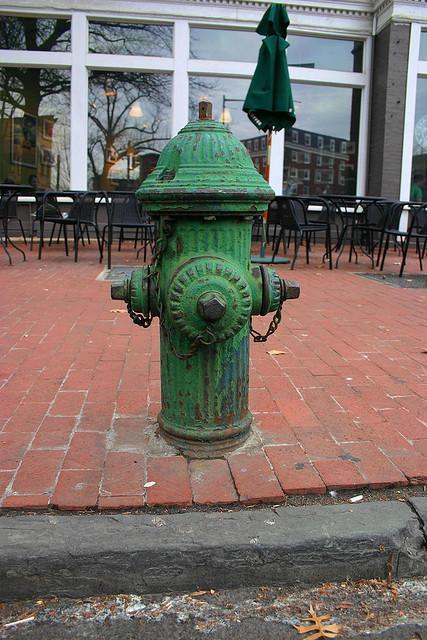How many objects can be easily moved?
Give a very brief answer. 10. How many beds are there?
Give a very brief answer. 0. 